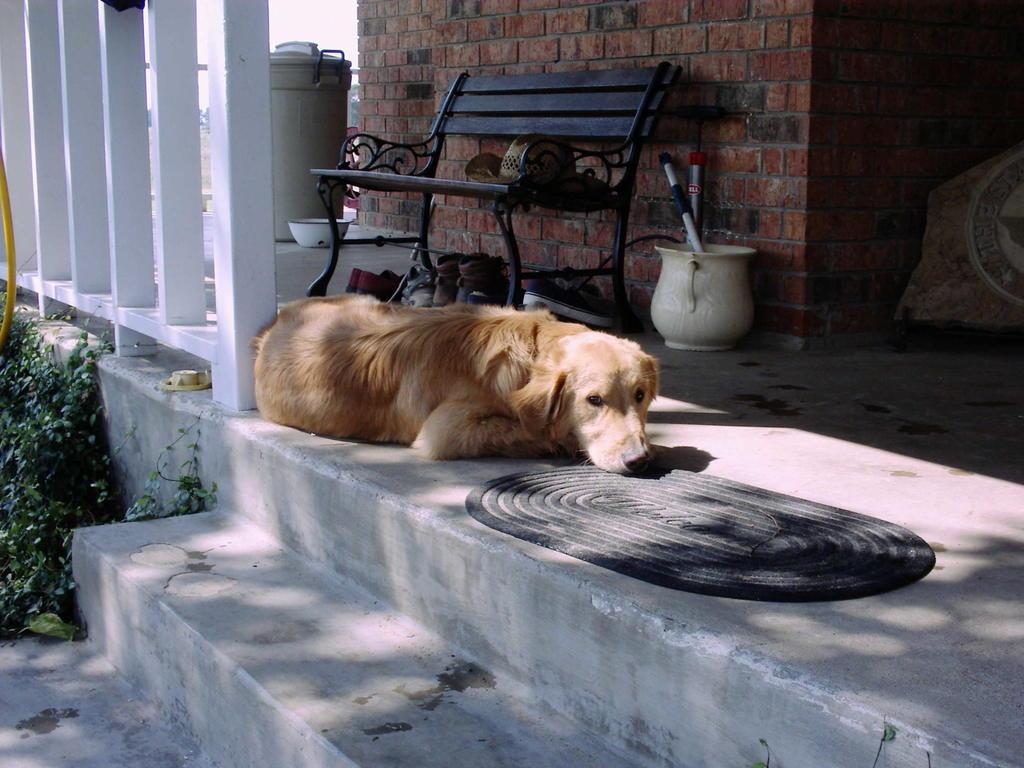In one or two sentences, can you explain what this image depicts? In this image I can see a dog in brown color, few plants in green color. Background I can a bench in brown color, a pot in cream color, wall in brown color and the sky is in white color. 